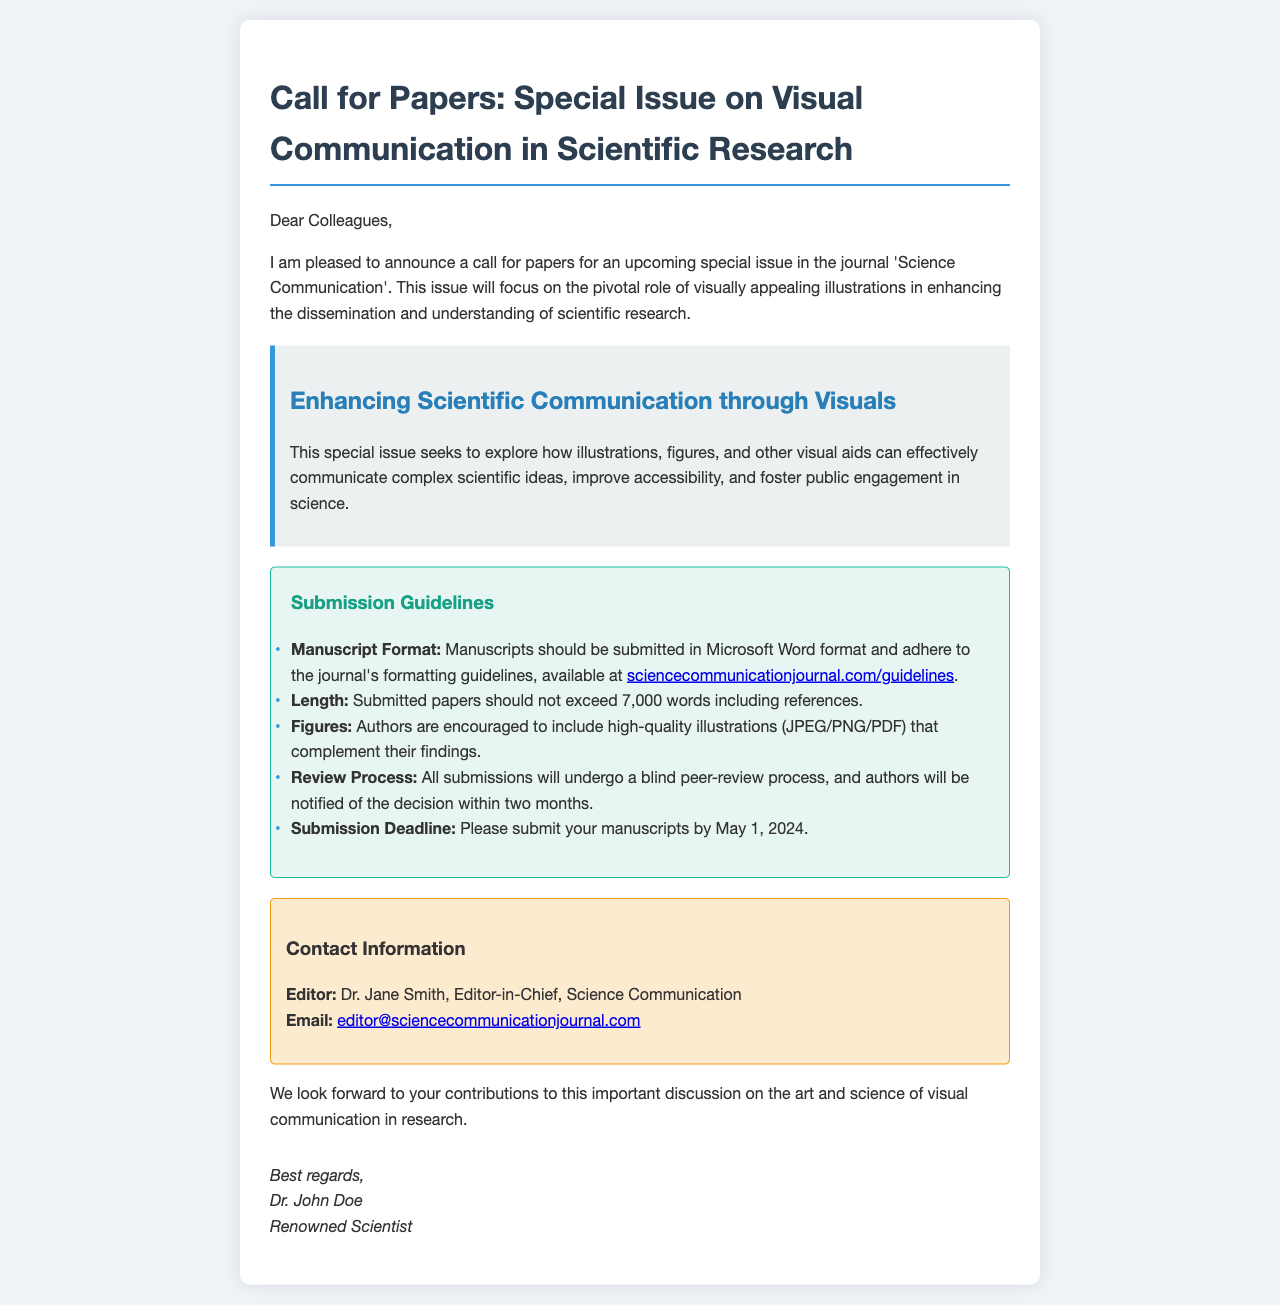What is the title of the special issue? The title is specifically mentioned at the beginning of the document, referring to the focus area of the call for papers.
Answer: Special Issue on Visual Communication in Scientific Research Who is the editor-in-chief? This information is included in the contact section, identifying the editor responsible for the special issue.
Answer: Dr. Jane Smith What is the submission deadline? The document clearly states the deadline for manuscript submissions under the guidelines section.
Answer: May 1, 2024 What is the maximum length of submitted papers? The length restriction is provided within the submission guidelines of the document.
Answer: 7,000 words What are authors encouraged to include in their submissions? This is specified in the guidelines, which mention the type of submission components authors should focus on.
Answer: High-quality illustrations What will happen to submitted papers? The document provides insight into the process that submitted papers will go through after submission.
Answer: Blind peer-review process What type of document is this? The structure and language of the document indicate its purpose within the academic community.
Answer: Call for papers email What is the main theme of the special issue? The thematic focus of the call for papers is articulated in a designated section within the document.
Answer: Enhancing Scientific Communication through Visuals 